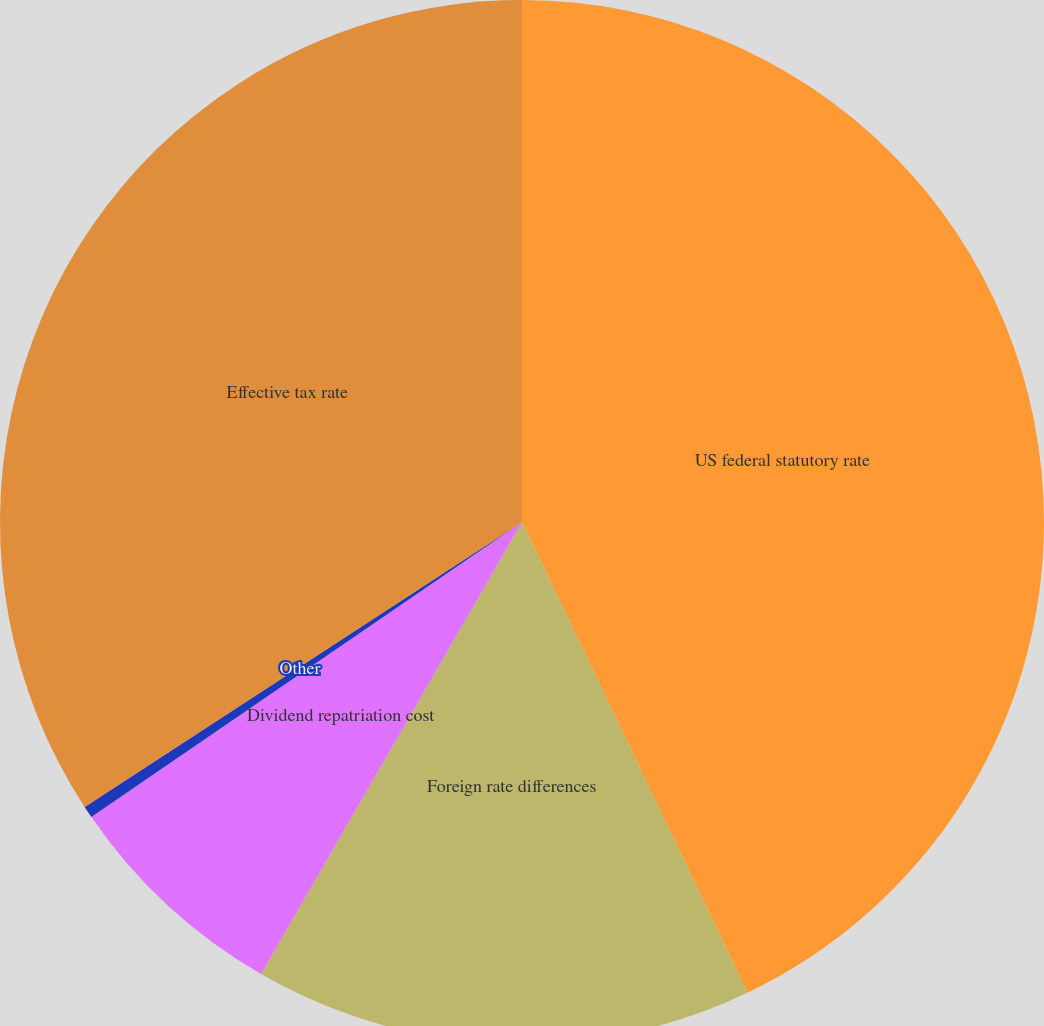Convert chart. <chart><loc_0><loc_0><loc_500><loc_500><pie_chart><fcel>US federal statutory rate<fcel>Foreign rate differences<fcel>Dividend repatriation cost<fcel>Other<fcel>Effective tax rate<nl><fcel>42.89%<fcel>15.44%<fcel>7.11%<fcel>0.37%<fcel>34.19%<nl></chart> 